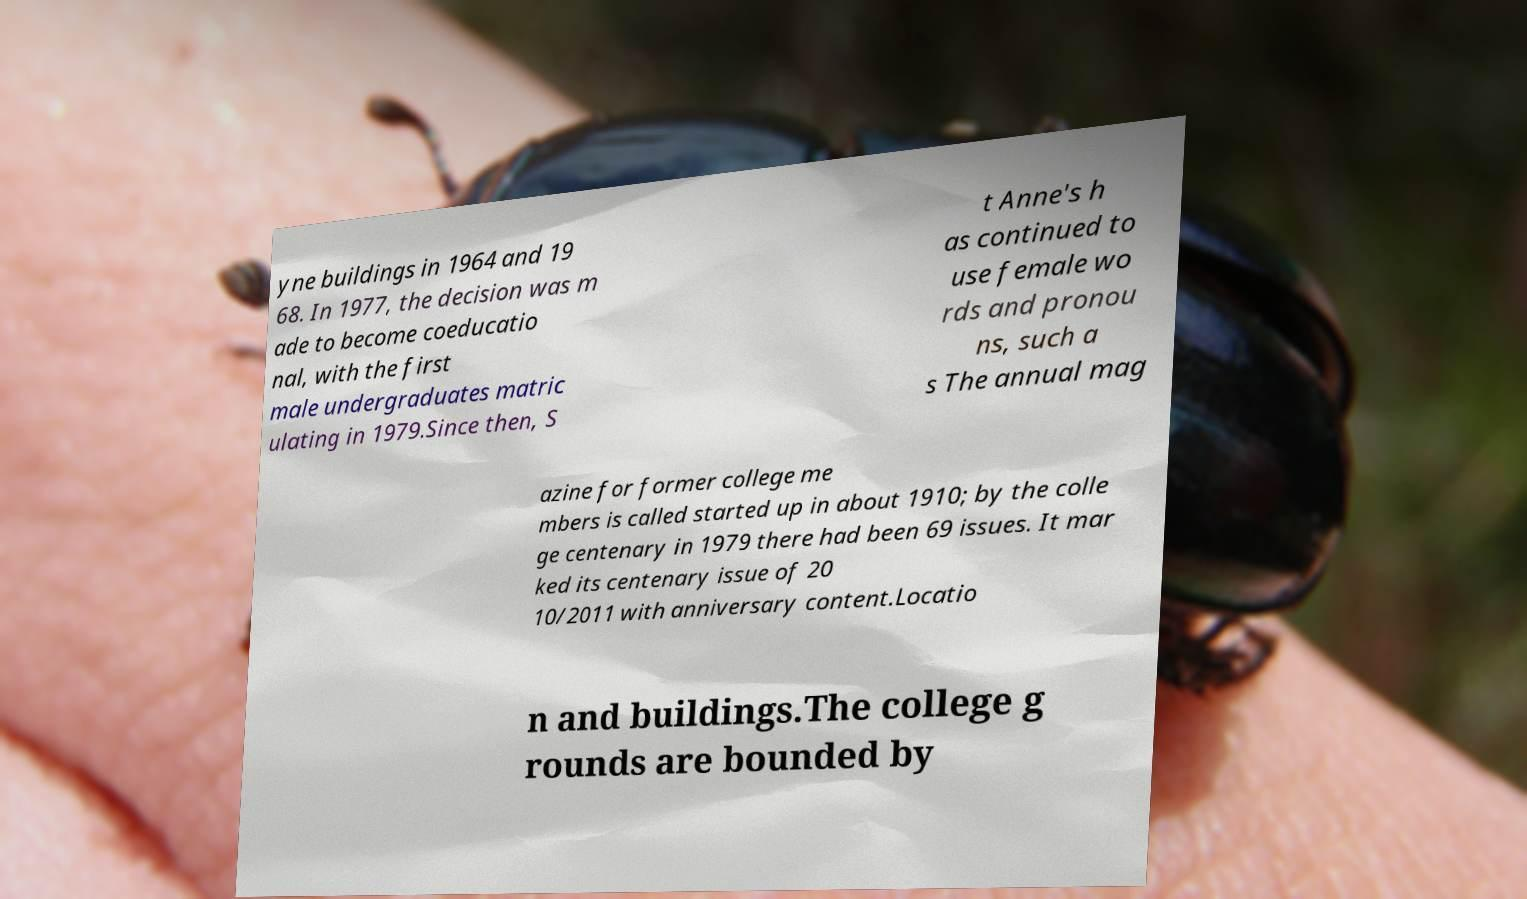Please identify and transcribe the text found in this image. yne buildings in 1964 and 19 68. In 1977, the decision was m ade to become coeducatio nal, with the first male undergraduates matric ulating in 1979.Since then, S t Anne's h as continued to use female wo rds and pronou ns, such a s The annual mag azine for former college me mbers is called started up in about 1910; by the colle ge centenary in 1979 there had been 69 issues. It mar ked its centenary issue of 20 10/2011 with anniversary content.Locatio n and buildings.The college g rounds are bounded by 